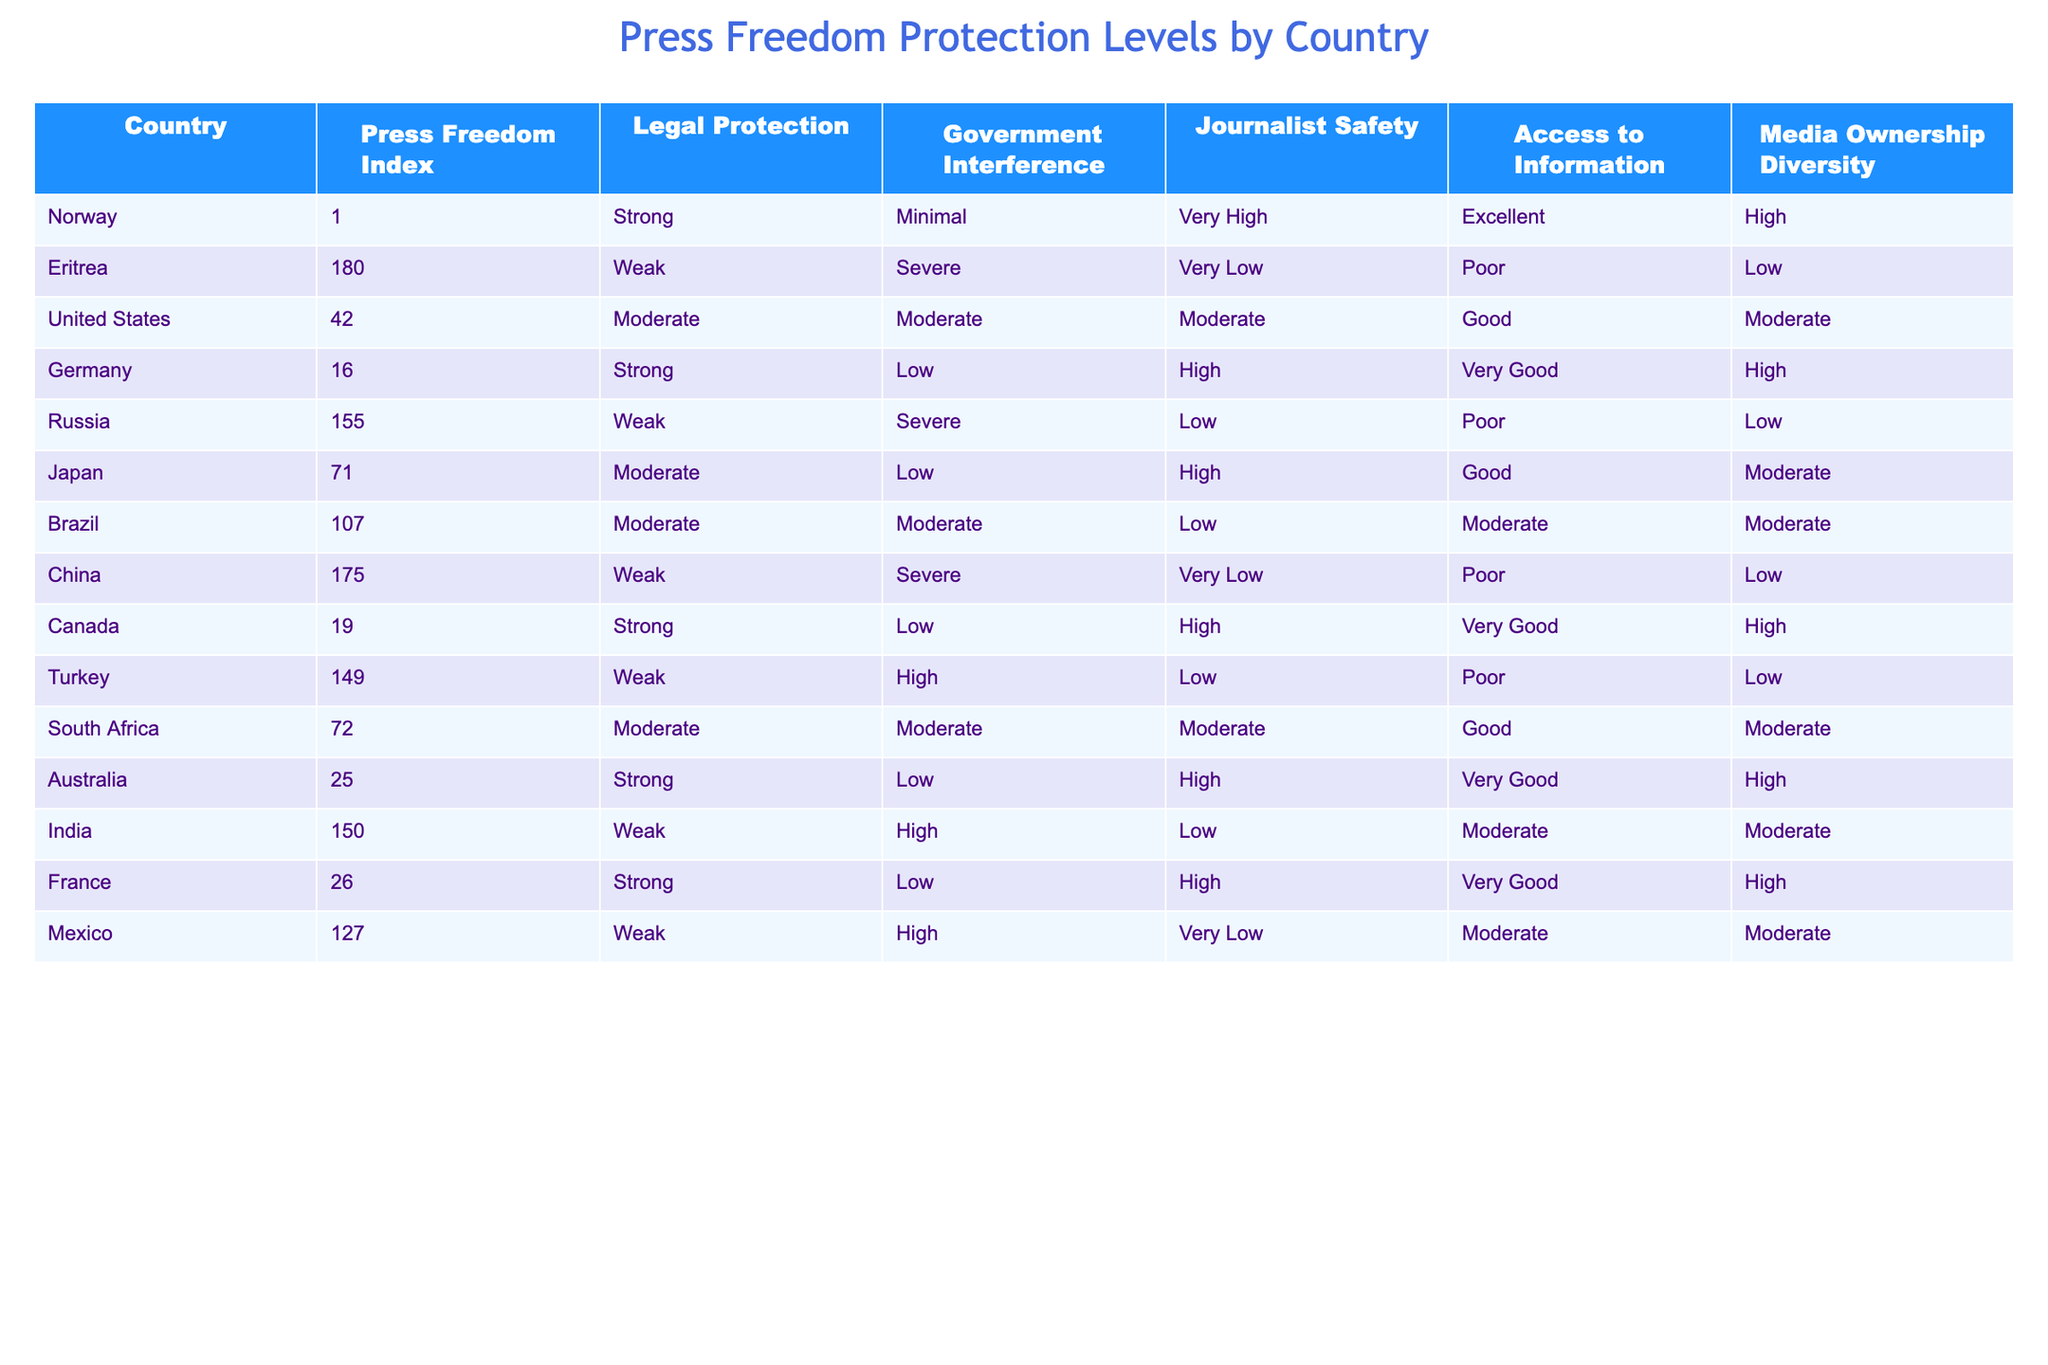What is the Press Freedom Index for Germany? According to the table, the Press Freedom Index for Germany is listed under the "Press Freedom Index" column. It directly states the value is 16.
Answer: 16 Which country has the highest Press Freedom Index? By reviewing the table's "Press Freedom Index" column, Norway has the lowest index value of 1, indicating it has the highest level of press freedom.
Answer: Norway How many countries have a strong legal protection for press freedom? From the table, we can see the countries listed with "Strong" under the "Legal Protection" column are Norway, Germany, Canada, Australia, and France, which total five countries.
Answer: 5 Is the Government Interference in the United States considered minimal? The table indicates that the "Government Interference" for the United States is categorized as "Moderate." Therefore, it is not minimal.
Answer: No What is the average Press Freedom Index of the countries with weak legal protection? First, identify the countries with weak legal protection: Eritrea (180), Russia (155), China (175), Turkey (149), and India (150). Adding these values together gives us 180 + 155 + 175 + 149 + 150 = 809. Since there are 5 countries, the average is 809 / 5 = 161.8.
Answer: 161.8 Which country has the least access to information among the listed countries? By examining the "Access to Information" column, we see that Eritrea and China both have "Very Low" access listed. Therefore, they are the countries with the least access to information.
Answer: Eritrea and China Is press freedom in Brazil worse than in the United States? Brazil has a Press Freedom Index of 107 and the United States has an Index of 42. Since a higher index indicates worse press freedom, Brazil's press freedom situation is indeed worse than that of the United States.
Answer: Yes How many countries have both high journalist safety and strong legal protection? Looking at the "Journalist Safety" and "Legal Protection" columns, we find Germany and Canada have "High" journalist safety and "Strong" legal protection. Hence, the total is two countries.
Answer: 2 